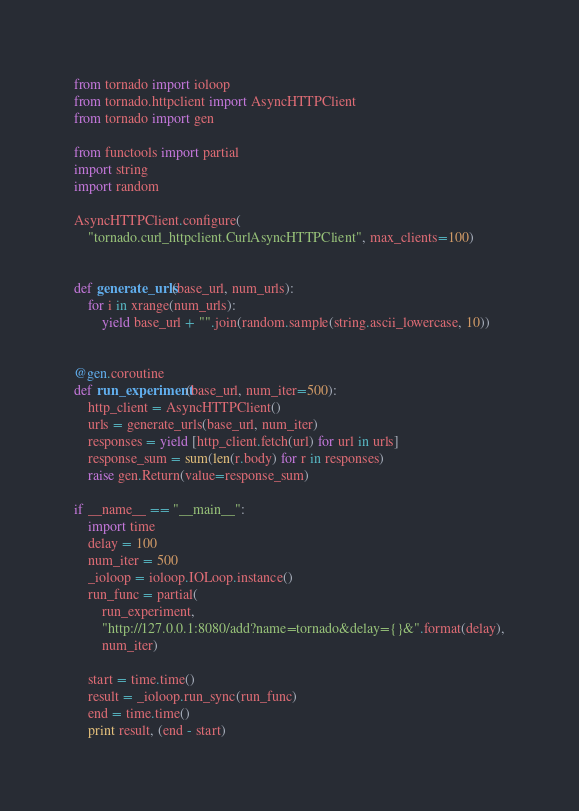Convert code to text. <code><loc_0><loc_0><loc_500><loc_500><_Python_>from tornado import ioloop
from tornado.httpclient import AsyncHTTPClient
from tornado import gen

from functools import partial
import string
import random

AsyncHTTPClient.configure(
    "tornado.curl_httpclient.CurlAsyncHTTPClient", max_clients=100)


def generate_urls(base_url, num_urls):
    for i in xrange(num_urls):
        yield base_url + "".join(random.sample(string.ascii_lowercase, 10))


@gen.coroutine
def run_experiment(base_url, num_iter=500):
    http_client = AsyncHTTPClient()
    urls = generate_urls(base_url, num_iter)
    responses = yield [http_client.fetch(url) for url in urls]
    response_sum = sum(len(r.body) for r in responses)
    raise gen.Return(value=response_sum)

if __name__ == "__main__":
    import time
    delay = 100
    num_iter = 500
    _ioloop = ioloop.IOLoop.instance()
    run_func = partial(
        run_experiment,
        "http://127.0.0.1:8080/add?name=tornado&delay={}&".format(delay),
        num_iter)

    start = time.time()
    result = _ioloop.run_sync(run_func)
    end = time.time()
    print result, (end - start)
</code> 